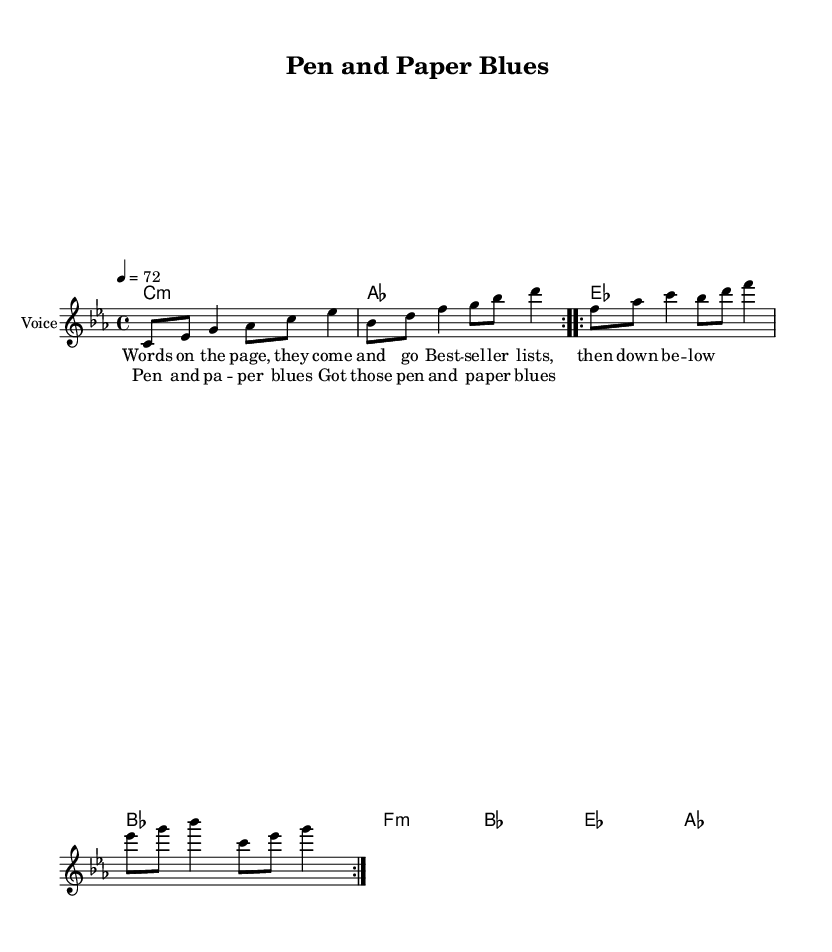What is the key signature of this music? The key signature is C minor, which is indicated by the three flat notes (B flat, E flat, and A flat) in the partiture.
Answer: C minor What is the time signature of this music? The time signature is shown at the beginning of the sheet music as 4/4, meaning there are four beats in each measure.
Answer: 4/4 What is the tempo of this music? The tempo marking, indicated by "4 = 72", shows that there should be 72 quarter-note beats per minute.
Answer: 72 How many measures are in the chorus? By counting the measures under the "chorus" lyric section, there are a total of two measures presented in the chorus.
Answer: 2 Which chord is played with the melody's first note? The first note of the melody (C) corresponds to the chord written in the harmonies section, which is a C minor chord.
Answer: C minor What lyrical theme is expressed in the verse one? The lyrical theme in the first verse reflects the transitory nature of success and setbacks in writing, capturing the emotional struggles of a creative career.
Answer: Creative struggle What is the primary musical genre of this piece? The style and characteristics of the song (such as the chord changes and vocal line) distinctly align with the rhythm, feel, and structure typical of soul music.
Answer: Soul 